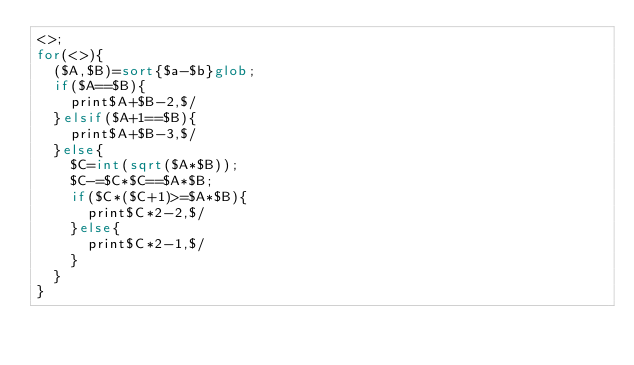Convert code to text. <code><loc_0><loc_0><loc_500><loc_500><_Perl_><>;
for(<>){
	($A,$B)=sort{$a-$b}glob;
	if($A==$B){
		print$A+$B-2,$/
	}elsif($A+1==$B){
		print$A+$B-3,$/
	}else{
		$C=int(sqrt($A*$B));
		$C-=$C*$C==$A*$B;
		if($C*($C+1)>=$A*$B){
			print$C*2-2,$/
		}else{
			print$C*2-1,$/
		}
	}
}
</code> 